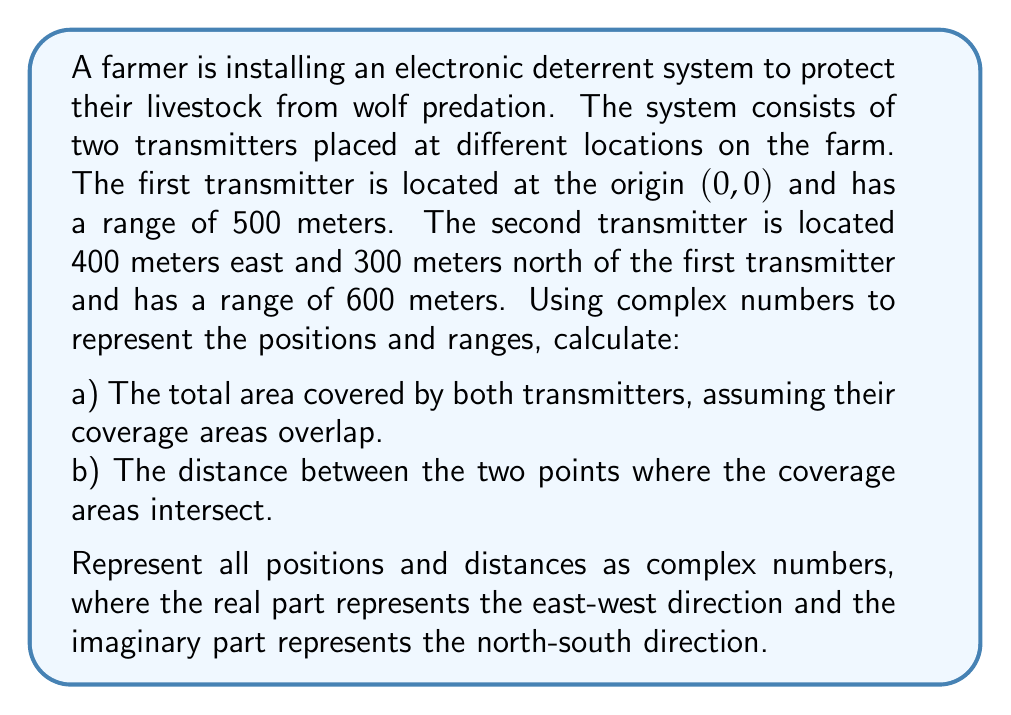What is the answer to this math problem? Let's approach this problem step by step using complex numbers:

1) First, let's represent the positions of the transmitters as complex numbers:
   Transmitter 1: $z_1 = 0 + 0i$
   Transmitter 2: $z_2 = 400 + 300i$

2) The ranges can be represented as circles in the complex plane. The equation of a circle with center $z_0$ and radius $r$ is:
   $|z - z_0| = r$

3) For the intersection points, we need to solve:
   $|z - z_1| = 500$ and $|z - z_2| = 600$

4) This system can be solved by subtracting one equation from the other:
   $|z| = 500$
   $|z - (400 + 300i)| = 600$
   
   $|z - (400 + 300i)| - |z| = 100$

5) This equation represents a hyperbola. The intersection points of this hyperbola with either circle are the points where the coverage areas intersect.

6) To find these points, we can use the fact that they are equidistant from the line connecting the two transmitters. This line has the equation:
   $y = \frac{3}{4}x$

7) Substituting this into the equation of the first circle:
   $x^2 + (\frac{3}{4}x)^2 = 500^2$

8) Solving this equation:
   $x^2 + \frac{9}{16}x^2 = 250000$
   $\frac{25}{16}x^2 = 250000$
   $x^2 = 160000$
   $x = \pm 400$

9) The intersection points are therefore:
   $z_3 = 400 + 300i$ and $z_4 = -400 - 300i$

10) The distance between these points is:
    $|z_4 - z_3| = |-800 - 600i| = \sqrt{800^2 + 600^2} = 1000$

11) To calculate the total area, we need to find the area of each circle and subtract the area of their overlap:
    Area of circle 1: $\pi r_1^2 = \pi(500^2) = 785398.16$ sq meters
    Area of circle 2: $\pi r_2^2 = \pi(600^2) = 1130973.36$ sq meters

12) The area of overlap can be calculated using the formula for the area of intersection of two circles:
    $A = r_1^2 \arccos(\frac{d^2 + r_1^2 - r_2^2}{2dr_1}) + r_2^2 \arccos(\frac{d^2 + r_2^2 - r_1^2}{2dr_2}) - \frac{1}{2}\sqrt{(-d+r_1+r_2)(d+r_1-r_2)(d-r_1+r_2)(d+r_1+r_2)}$

    Where $d = |z_2 - z_1| = \sqrt{400^2 + 300^2} = 500$

13) Calculating this gives an overlap area of approximately 471238.90 sq meters.

14) Therefore, the total area covered is:
    $785398.16 + 1130973.36 - 471238.90 = 1445132.62$ sq meters
Answer: a) The total area covered by both transmitters is approximately 1445132.62 square meters.
b) The distance between the two points where the coverage areas intersect is 1000 meters, represented by the complex number $800 + 600i$. 